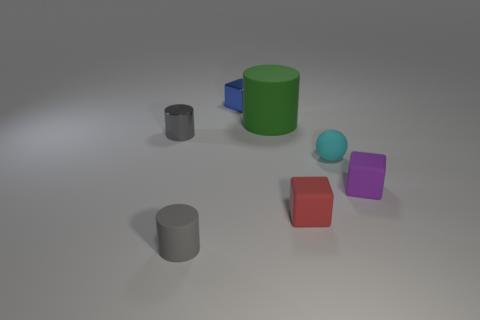What is the color of the matte cylinder that is the same size as the purple cube?
Keep it short and to the point. Gray. Is the number of tiny cyan spheres that are on the left side of the large matte cylinder the same as the number of tiny red matte things behind the small blue cube?
Offer a very short reply. Yes. What material is the small object that is left of the matte object that is in front of the red matte thing made of?
Provide a short and direct response. Metal. How many objects are small cylinders or tiny metallic things?
Keep it short and to the point. 3. What is the size of the metallic thing that is the same color as the small matte cylinder?
Your answer should be compact. Small. Are there fewer tiny things than gray cylinders?
Your response must be concise. No. There is a ball that is the same material as the purple object; what is its size?
Make the answer very short. Small. How big is the red object?
Provide a succinct answer. Small. What is the shape of the small blue thing?
Offer a terse response. Cube. There is a small matte thing that is in front of the red block; is its color the same as the large rubber thing?
Offer a very short reply. No. 